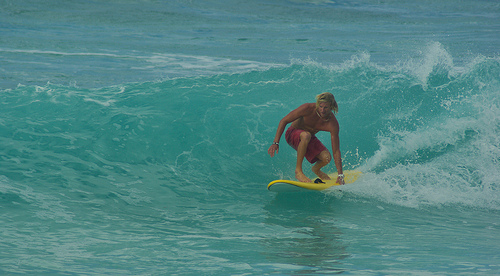Who is wearing the shorts? The individual masterfully riding the wave, known as the surfer, is wearing the shorts. 